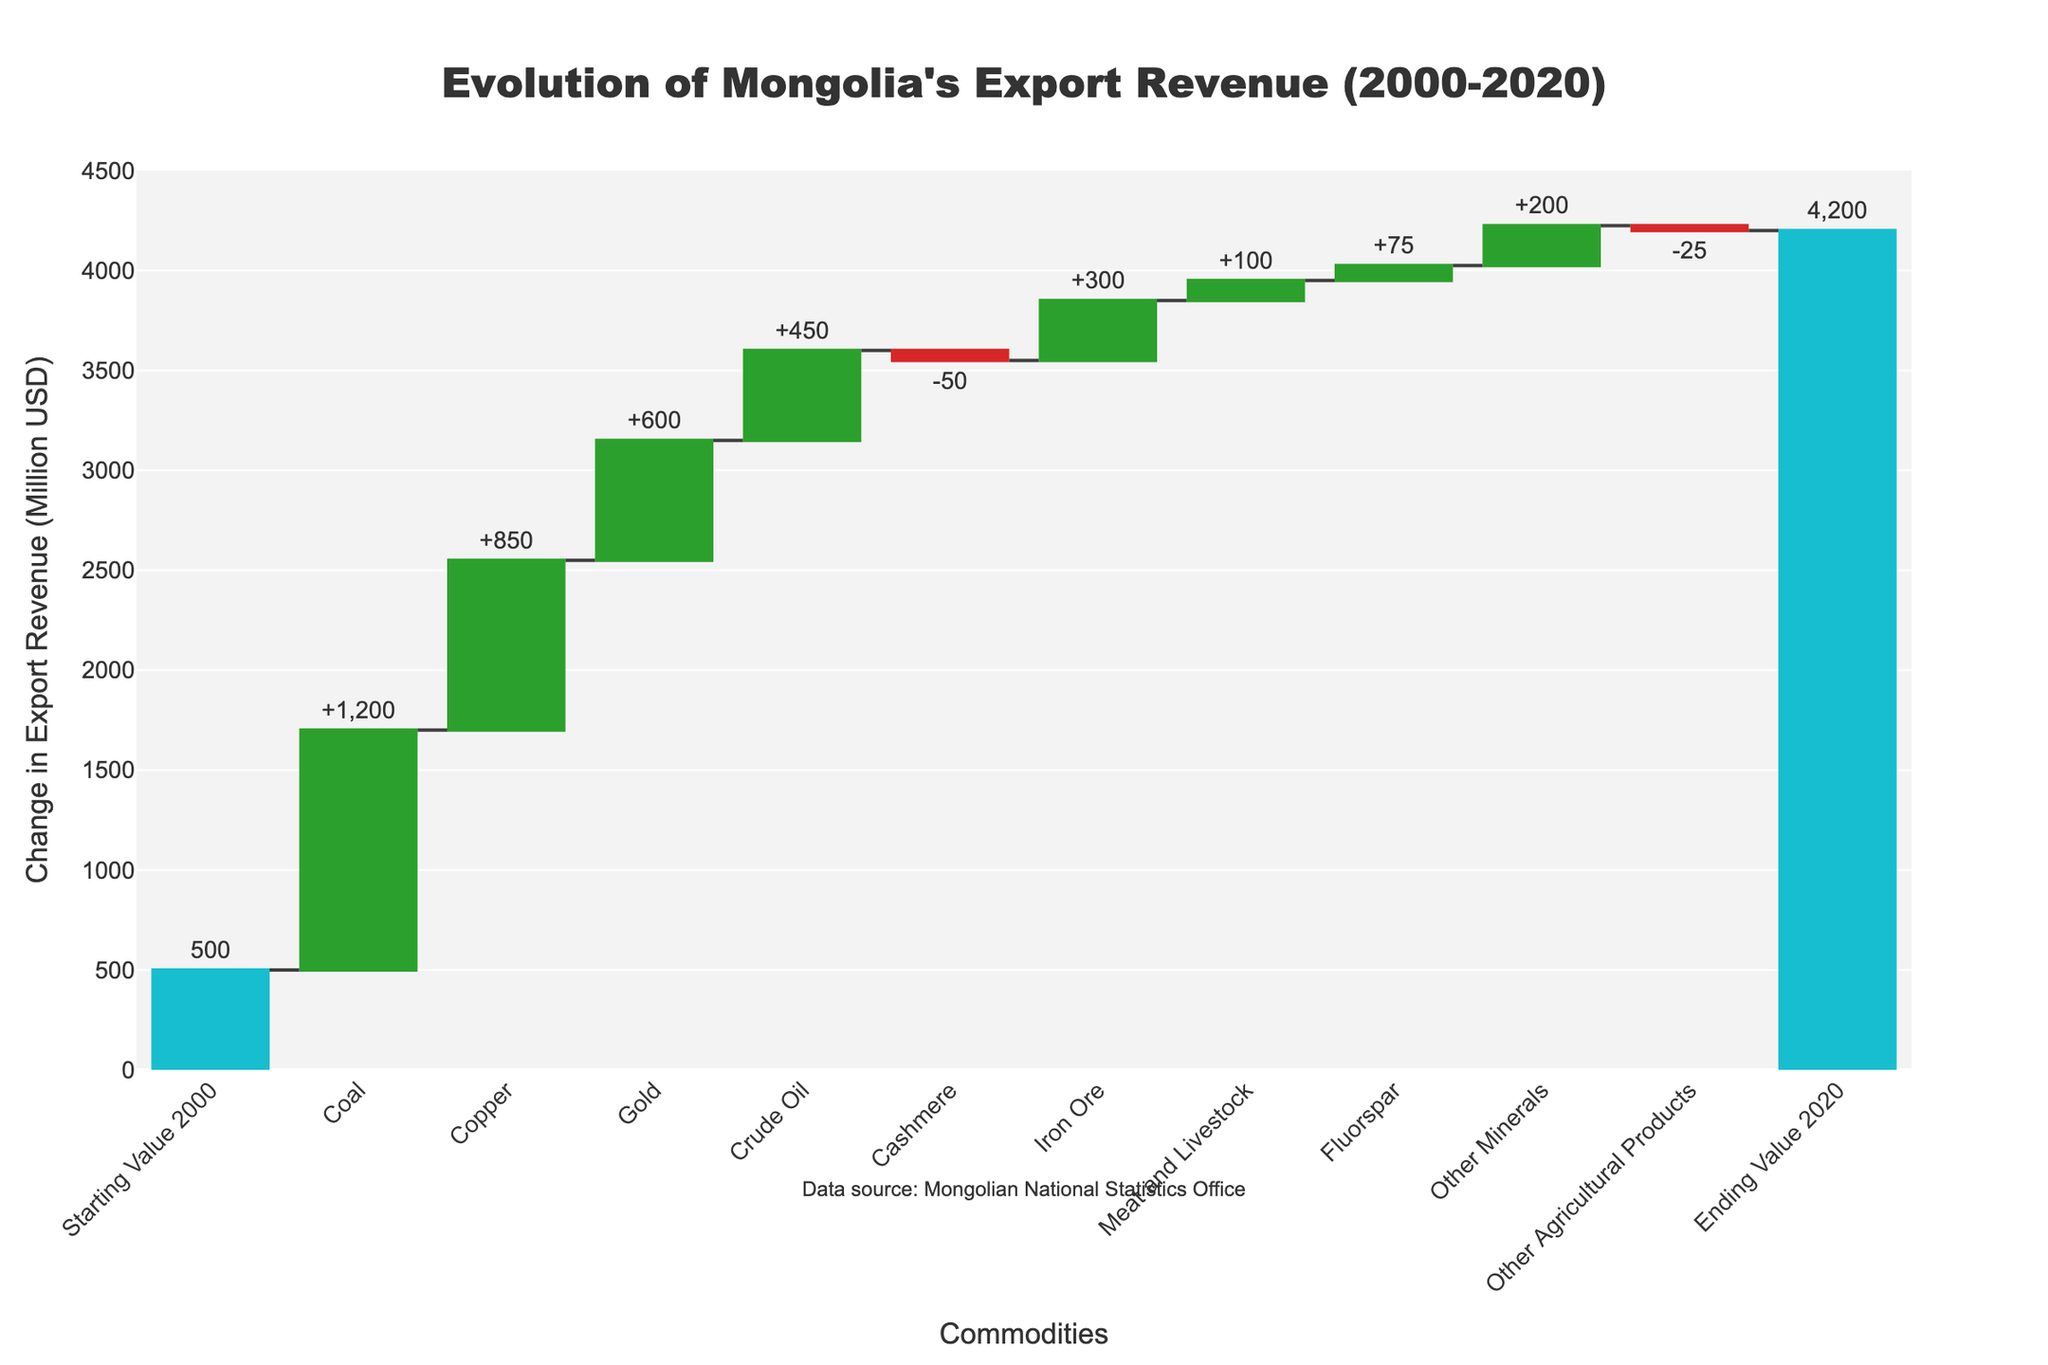What is the total change in export revenue from the starting value in 2000 to the ending value in 2020? By looking at the starting value (500 million USD) and the ending value (4200 million USD), we can subtract the starting value from the ending value to find the total change: 4200 - 500.
Answer: 3700 million USD Which commodity contributed the most to the increase in Mongolia's export revenue? By examining each commodity's contribution, the commodity with the largest positive change is Coal, adding 1200 million USD to the export revenue.
Answer: Coal How did Cashmere affect Mongolia's export revenue between 2000 and 2020? Cashmere's impact is represented by a negative change in the figure, specifically -50 million USD. It decreased the export revenue.
Answer: -50 million USD Which two commodities combined have the smallest total contribution to the change in export revenue? Summing all contributions, the smallest contributions are Cashmere (-50 million USD) and Other Agricultural Products (-25 million USD). Their combined total is -75 million USD.
Answer: Cashmere and Other Agricultural Products How much did Fluorspar and Other Minerals together contribute to the export revenue change? Adding the contributions of Fluorspar (75 million USD) and Other Minerals (200 million USD) produces a total contribution of 75 + 200.
Answer: 275 million USD Between Crude Oil and Iron Ore, which had the higher impact on the change in export revenue? Comparing the positive changes, Crude Oil contributed 450 million USD, while Iron Ore contributed 300 million USD. Thus, Crude Oil had a higher impact.
Answer: Crude Oil What is the net change in revenue for the agricultural products category (Cashmere and Other Agricultural Products)? Cashmere reduced by 50 million USD, and Other Agricultural Products by 25 million USD, making the net change a sum of -50 + -25.
Answer: -75 million USD Which commodity had a marginal impact (positive or negative) compared to Gold, and by how much? Gold increased revenue by 600 million USD. Comparing with Cashmere (-50 million USD), the marginal change is 600 - (-50).
Answer: Cashmere and 650 million USD 